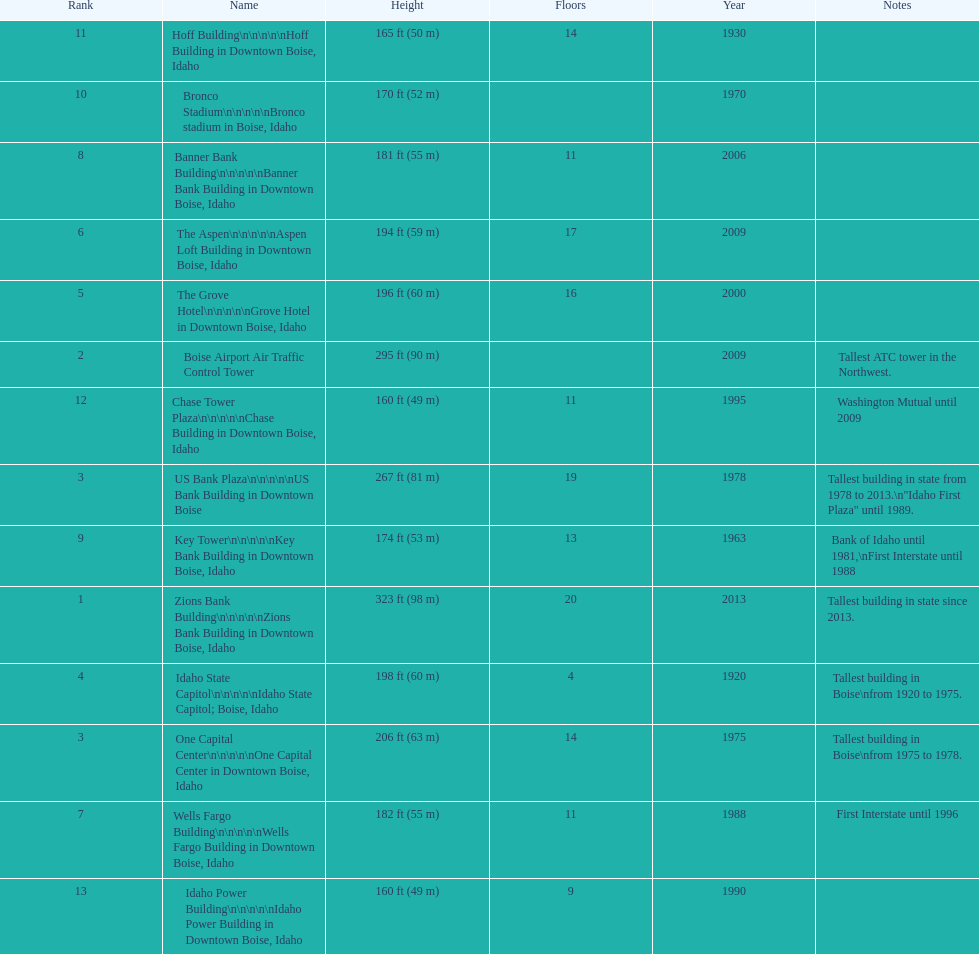How tall (in meters) is the tallest building? 98 m. 